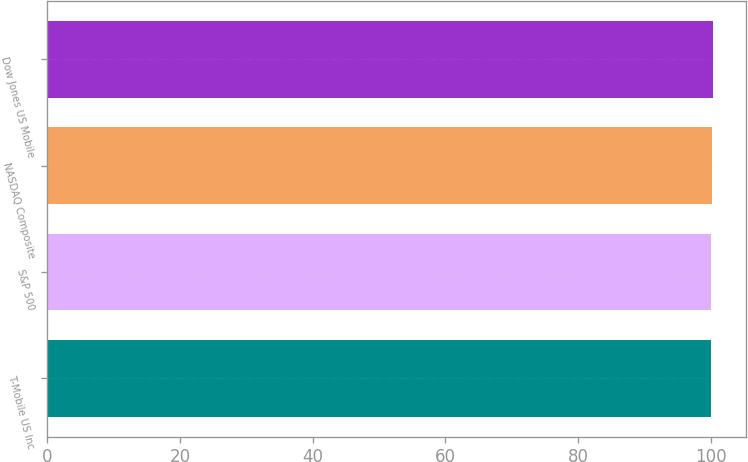<chart> <loc_0><loc_0><loc_500><loc_500><bar_chart><fcel>T-Mobile US Inc<fcel>S&P 500<fcel>NASDAQ Composite<fcel>Dow Jones US Mobile<nl><fcel>100<fcel>100.1<fcel>100.2<fcel>100.3<nl></chart> 